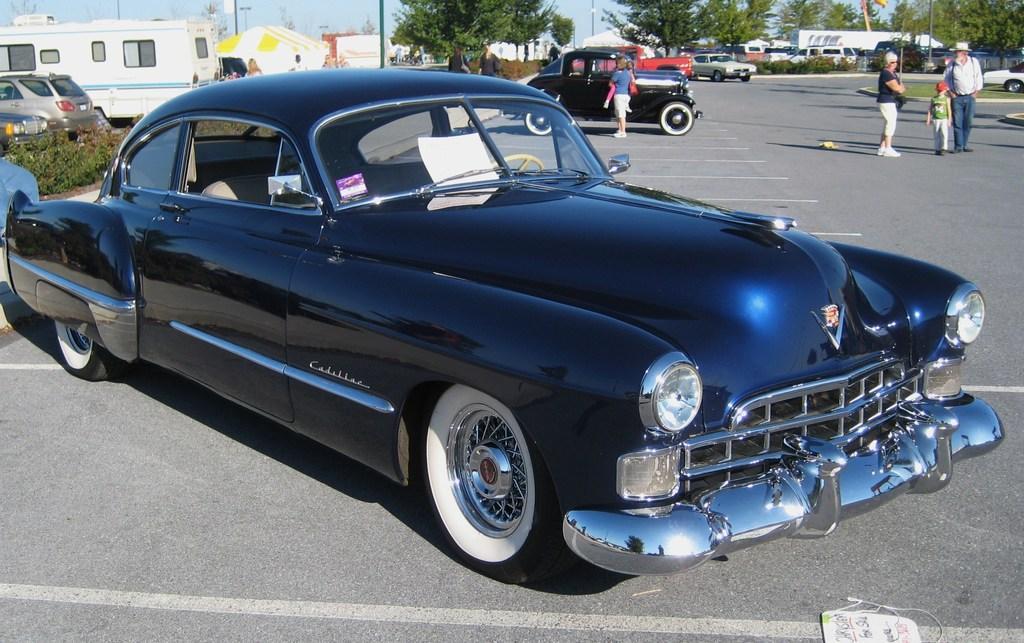Please provide a concise description of this image. In this image in the front there is a car which is black in colour. In the background there are trees, persons, cars, poles and there is grass on the ground and there are tents. 